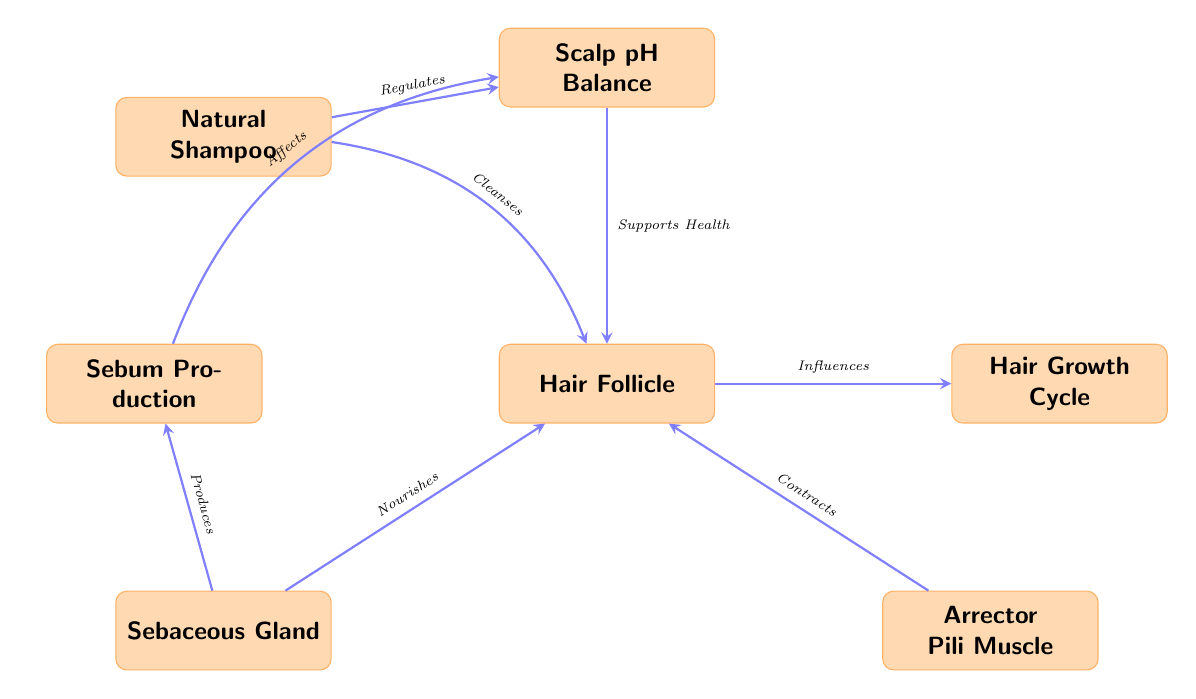What is the central node in the diagram? The central node is the "Hair Follicle," which connects various other nodes in the diagram, demonstrating its significance in the overall context of hair anatomy.
Answer: Hair Follicle How many nodes are there in total? By counting each distinct box in the diagram, we find seven nodes related to the anatomy of the hair follicle and its interactions with natural grooming products.
Answer: 7 What does the arrow from "Natural Shampoo" to "Hair Follicle" indicate? This arrow represents the action "Cleanses," showing that the natural shampoo directly cleanses the hair follicle.
Answer: Cleanses Which node is associated with regulating scalp pH balance? The node connected to regulating scalp pH balance is "Natural Shampoo," as it influences the pH level condition, which is important for hair follicle health.
Answer: Natural Shampoo What effect does "Sebum Production" have on "Scalp pH Balance"? "Sebum Production" affects the "Scalp pH Balance" indirectly; the arrow from "Sebum Production" indicates that it plays a role in influencing the scalp’s pH condition.
Answer: Affects Describe the relationship between "Hair Follicle" and "Hair Growth Cycle." The "Hair Follicle" influences the "Hair Growth Cycle," meaning that the health and function of the follicle directly impact how hair grows and transitions through its life stages.
Answer: Influences What does the "Sebaceous Gland" do in relation to the "Hair Follicle"? The "Sebaceous Gland" nourishes the "Hair Follicle," indicating that it provides essential oils or nutrients needed for follicle health and function.
Answer: Nourishes Which node is responsible for hair contraction? The node responsible for hair contraction is the "Arrector Pili Muscle," which is directly linked to the follicle and plays a role in the contraction mechanism.
Answer: Arrector Pili Muscle 